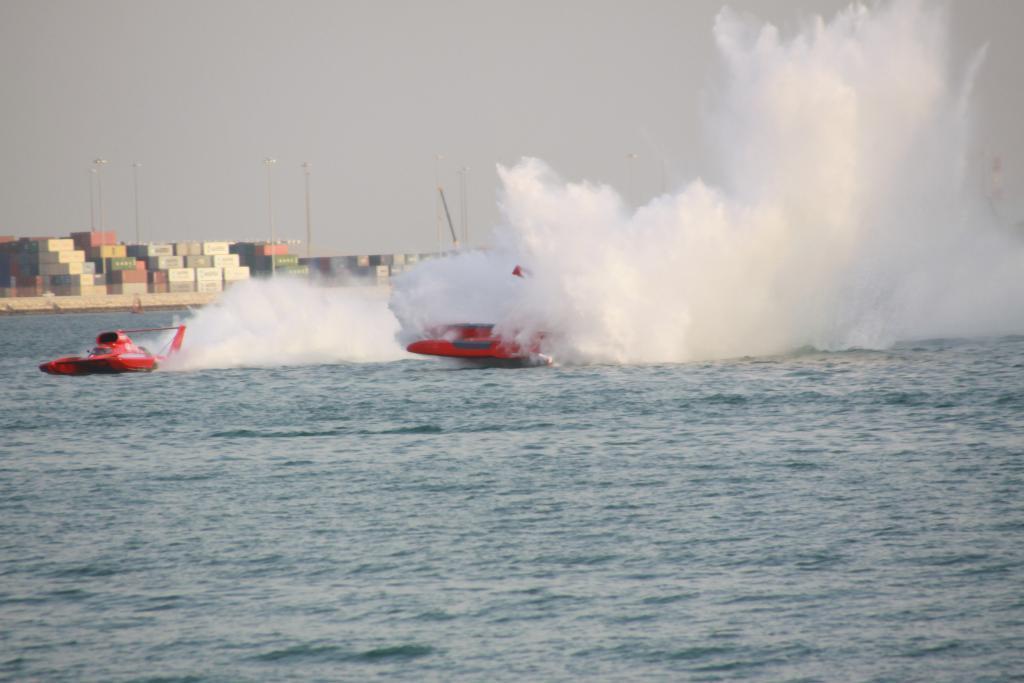Please provide a concise description of this image. In this image we can see speed boats, poles, water and in the background we can see the sky. 